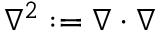Convert formula to latex. <formula><loc_0><loc_0><loc_500><loc_500>\nabla ^ { 2 } \colon = \nabla \cdot \nabla</formula> 